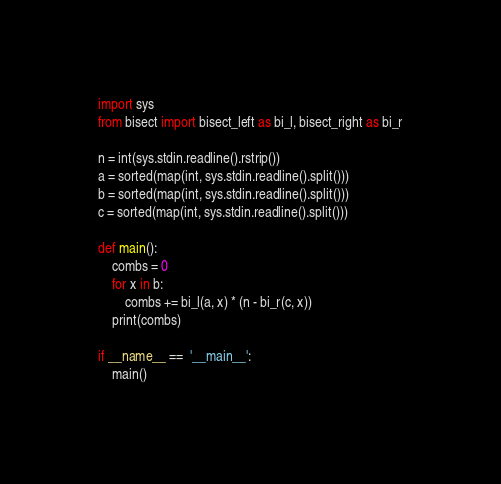<code> <loc_0><loc_0><loc_500><loc_500><_Python_>import sys
from bisect import bisect_left as bi_l, bisect_right as bi_r

n = int(sys.stdin.readline().rstrip())
a = sorted(map(int, sys.stdin.readline().split()))
b = sorted(map(int, sys.stdin.readline().split()))
c = sorted(map(int, sys.stdin.readline().split()))

def main():
    combs = 0
    for x in b:
        combs += bi_l(a, x) * (n - bi_r(c, x))
    print(combs)

if __name__ ==  '__main__':
    main()</code> 